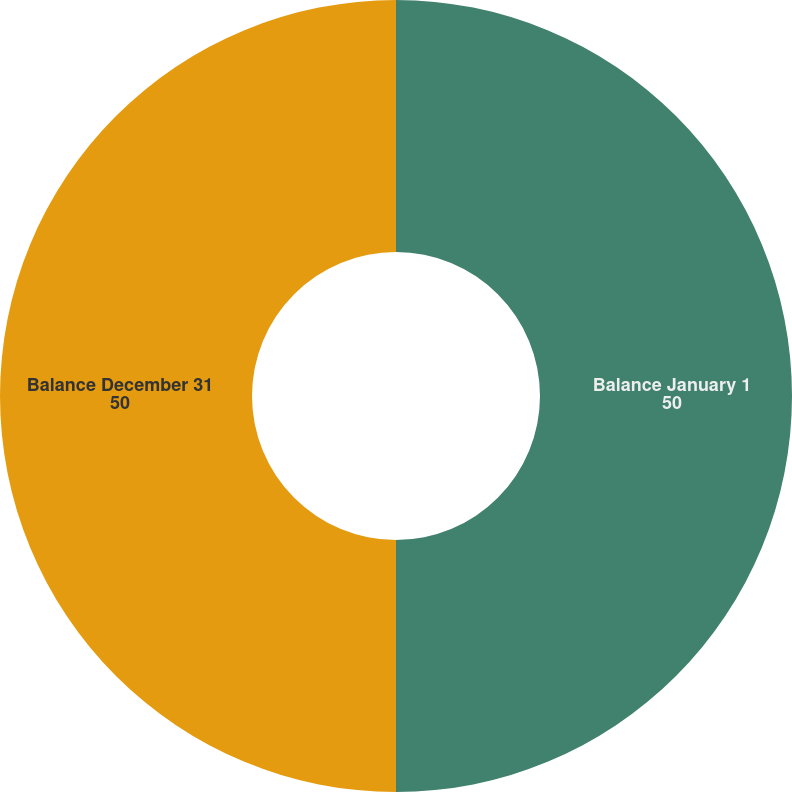Convert chart. <chart><loc_0><loc_0><loc_500><loc_500><pie_chart><fcel>Balance January 1<fcel>Balance December 31<nl><fcel>50.0%<fcel>50.0%<nl></chart> 